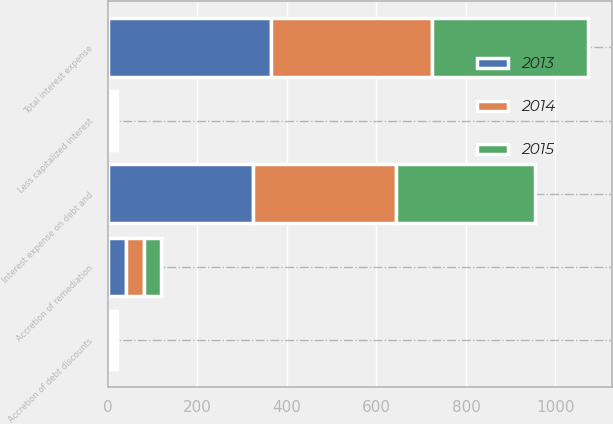Convert chart. <chart><loc_0><loc_0><loc_500><loc_500><stacked_bar_chart><ecel><fcel>Interest expense on debt and<fcel>Accretion of debt discounts<fcel>Accretion of remediation<fcel>Less capitalized interest<fcel>Total interest expense<nl><fcel>2013<fcel>324.6<fcel>7.4<fcel>39.7<fcel>6.8<fcel>364.9<nl><fcel>2015<fcel>310.3<fcel>6.6<fcel>38.2<fcel>6.4<fcel>348.7<nl><fcel>2014<fcel>319.8<fcel>6.9<fcel>40.6<fcel>7.3<fcel>360<nl></chart> 